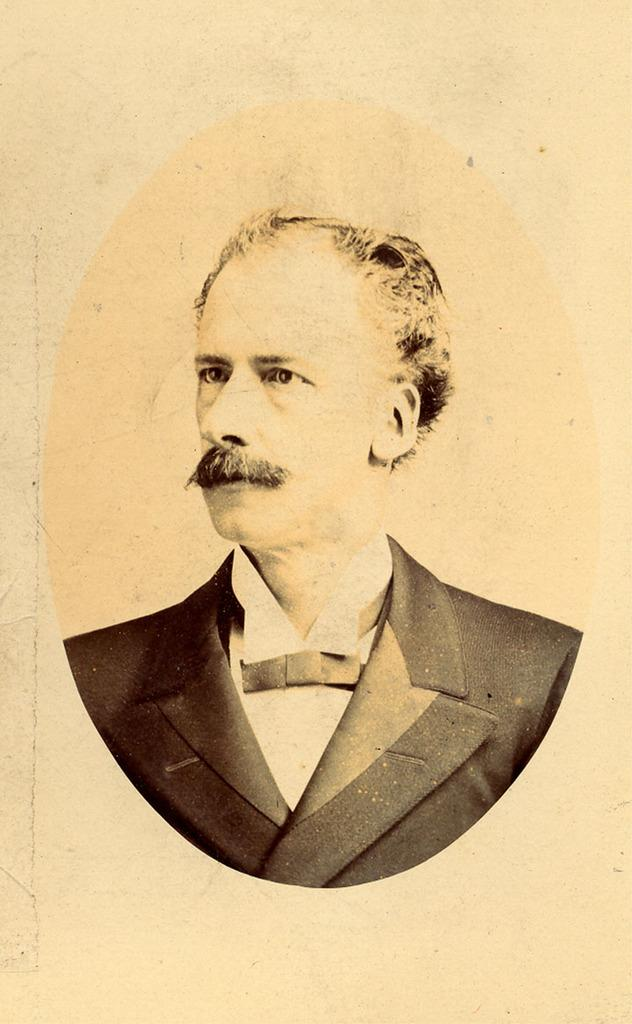What is the main subject of the image? The main subject of the image is a picture of a man on a paper. Can you describe the man in the picture? Unfortunately, the image does not provide enough detail to describe the man in the picture. What is the medium of the man's image? The man's image is on a paper. What type of fog can be seen in the image? There is no fog present in the image; it only features a picture of a man on a paper. 